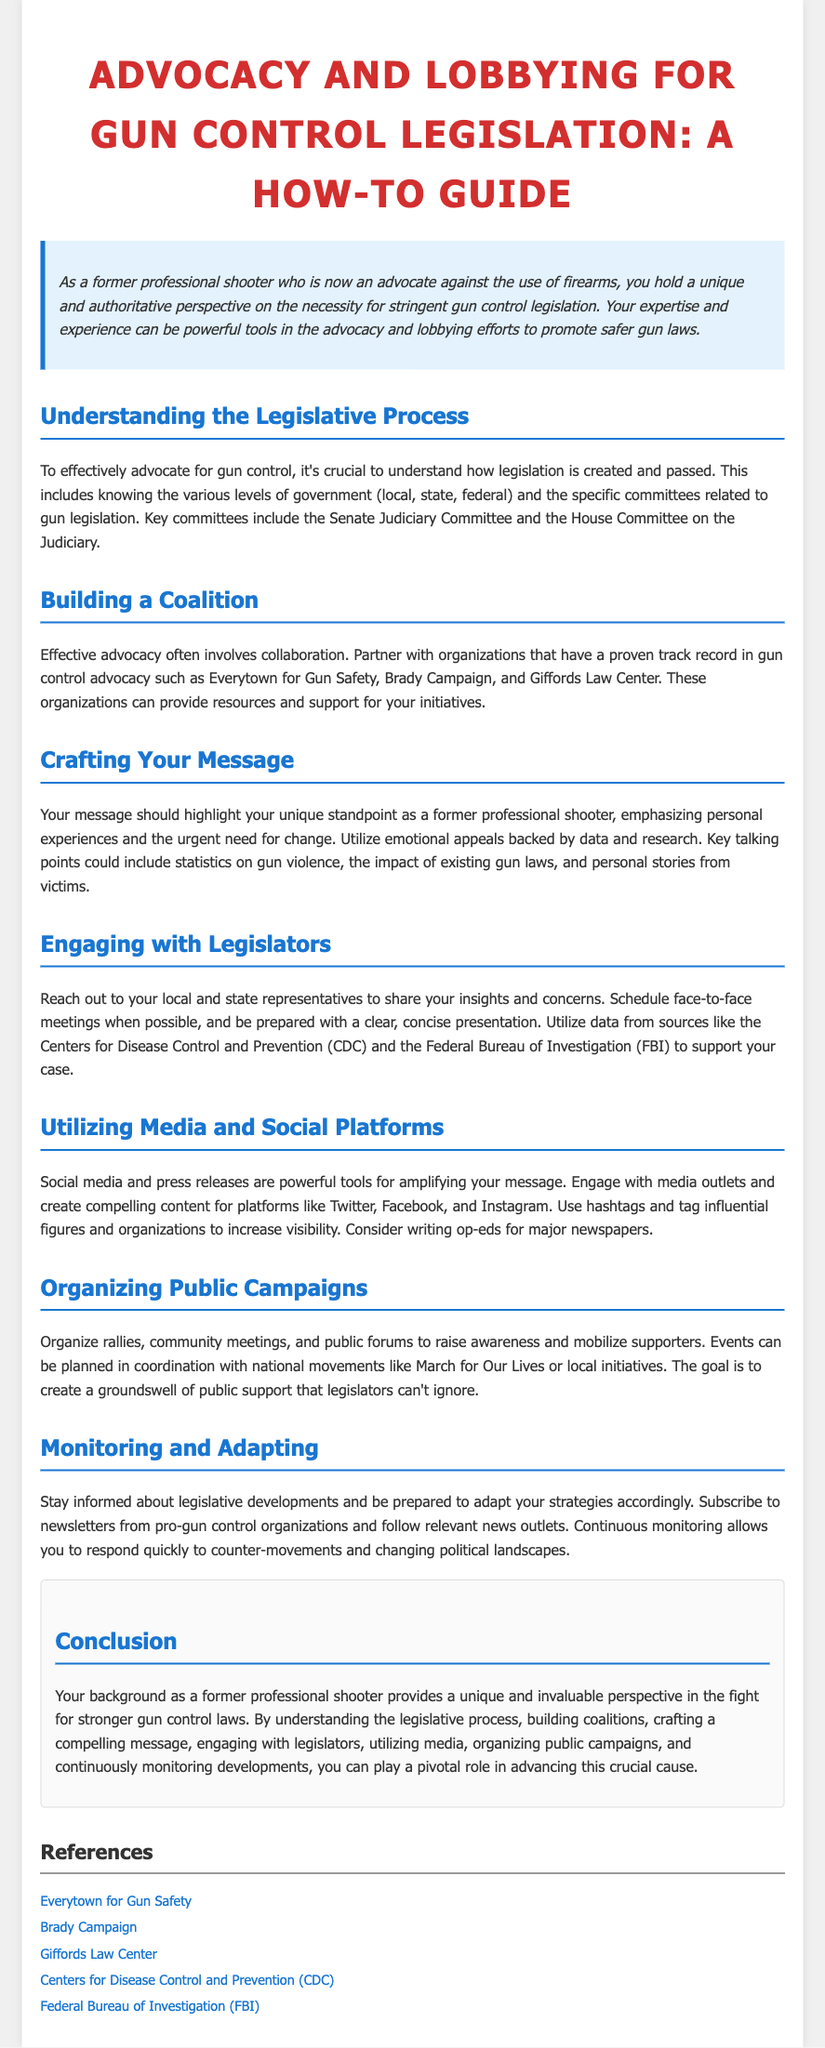What is the main topic of the document? The main topic of the document is advocacy and lobbying for gun control legislation.
Answer: Advocacy and lobbying for gun control legislation Who should advocates partner with according to the guide? The guide recommends partnering with organizations like Everytown for Gun Safety, Brady Campaign, and Giffords Law Center.
Answer: Everytown for Gun Safety, Brady Campaign, Giffords Law Center What should advocates emphasize in their message? Advocates should emphasize their unique standpoint as a former professional shooter and the urgent need for change.
Answer: Unique standpoint and urgent need for change What is one of the goals when organizing public campaigns? One of the goals is to create a groundswell of public support that legislators can't ignore.
Answer: Create a groundswell of public support Which committee is mentioned as key for gun legislation? The Senate Judiciary Committee is mentioned as a key committee for gun legislation.
Answer: Senate Judiciary Committee How should advocates engage with legislators? Advocates should reach out to local and state representatives and schedule face-to-face meetings.
Answer: Reach out and schedule face-to-face meetings What type of content should be created for media platforms? Compelling content should be created for social media and press releases.
Answer: Compelling content What should advocates do to stay informed about legislation? Advocates should subscribe to newsletters from pro-gun control organizations and follow relevant news outlets.
Answer: Subscribe to newsletters and follow news outlets What is the document's conclusion about the advocate's background? The conclusion states that the advocate's background provides a unique and invaluable perspective in the fight for stronger gun control laws.
Answer: Unique and invaluable perspective 